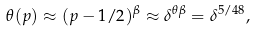<formula> <loc_0><loc_0><loc_500><loc_500>\theta ( p ) \approx ( p - 1 / 2 ) ^ { \beta } \approx \delta ^ { \theta \beta } = \delta ^ { 5 / 4 8 } ,</formula> 